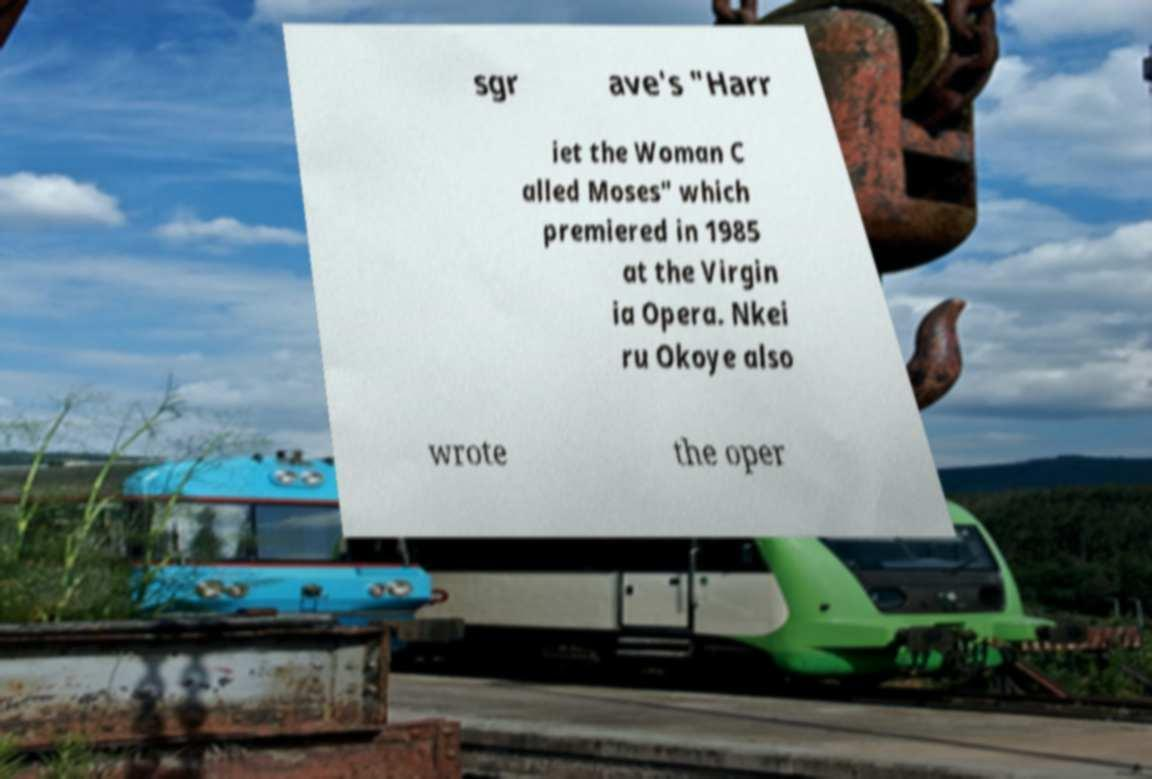There's text embedded in this image that I need extracted. Can you transcribe it verbatim? sgr ave's "Harr iet the Woman C alled Moses" which premiered in 1985 at the Virgin ia Opera. Nkei ru Okoye also wrote the oper 